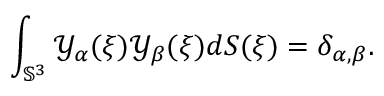Convert formula to latex. <formula><loc_0><loc_0><loc_500><loc_500>\int _ { { \mathbb { S } } ^ { 3 } } { \ m a t h s c r Y } _ { \alpha } ( \xi ) { \ m a t h s c r Y } _ { \beta } ( \xi ) d S ( \xi ) = \delta _ { \alpha , \beta } .</formula> 